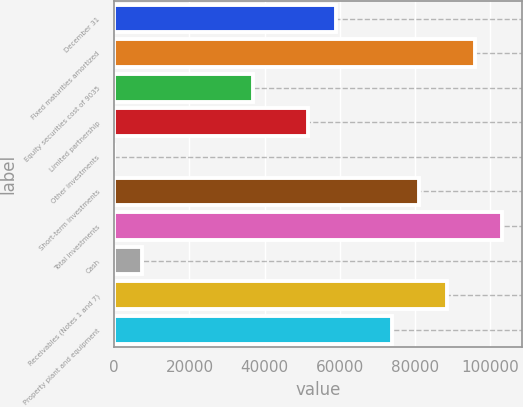Convert chart to OTSL. <chart><loc_0><loc_0><loc_500><loc_500><bar_chart><fcel>December 31<fcel>Fixed maturities amortized<fcel>Equity securities cost of 9035<fcel>Limited partnership<fcel>Other investments<fcel>Short-term investments<fcel>Total investments<fcel>Cash<fcel>Receivables (Notes 1 and 7)<fcel>Property plant and equipment<nl><fcel>58984.7<fcel>95823.8<fcel>36881.2<fcel>51616.8<fcel>42.1<fcel>81088.1<fcel>103192<fcel>7409.92<fcel>88455.9<fcel>73720.3<nl></chart> 